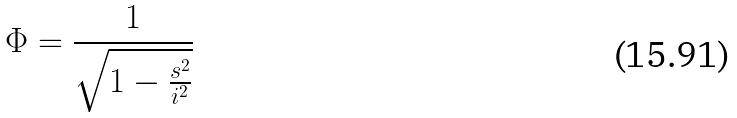<formula> <loc_0><loc_0><loc_500><loc_500>\Phi = \frac { 1 } { \sqrt { 1 - \frac { s ^ { 2 } } { i ^ { 2 } } } }</formula> 